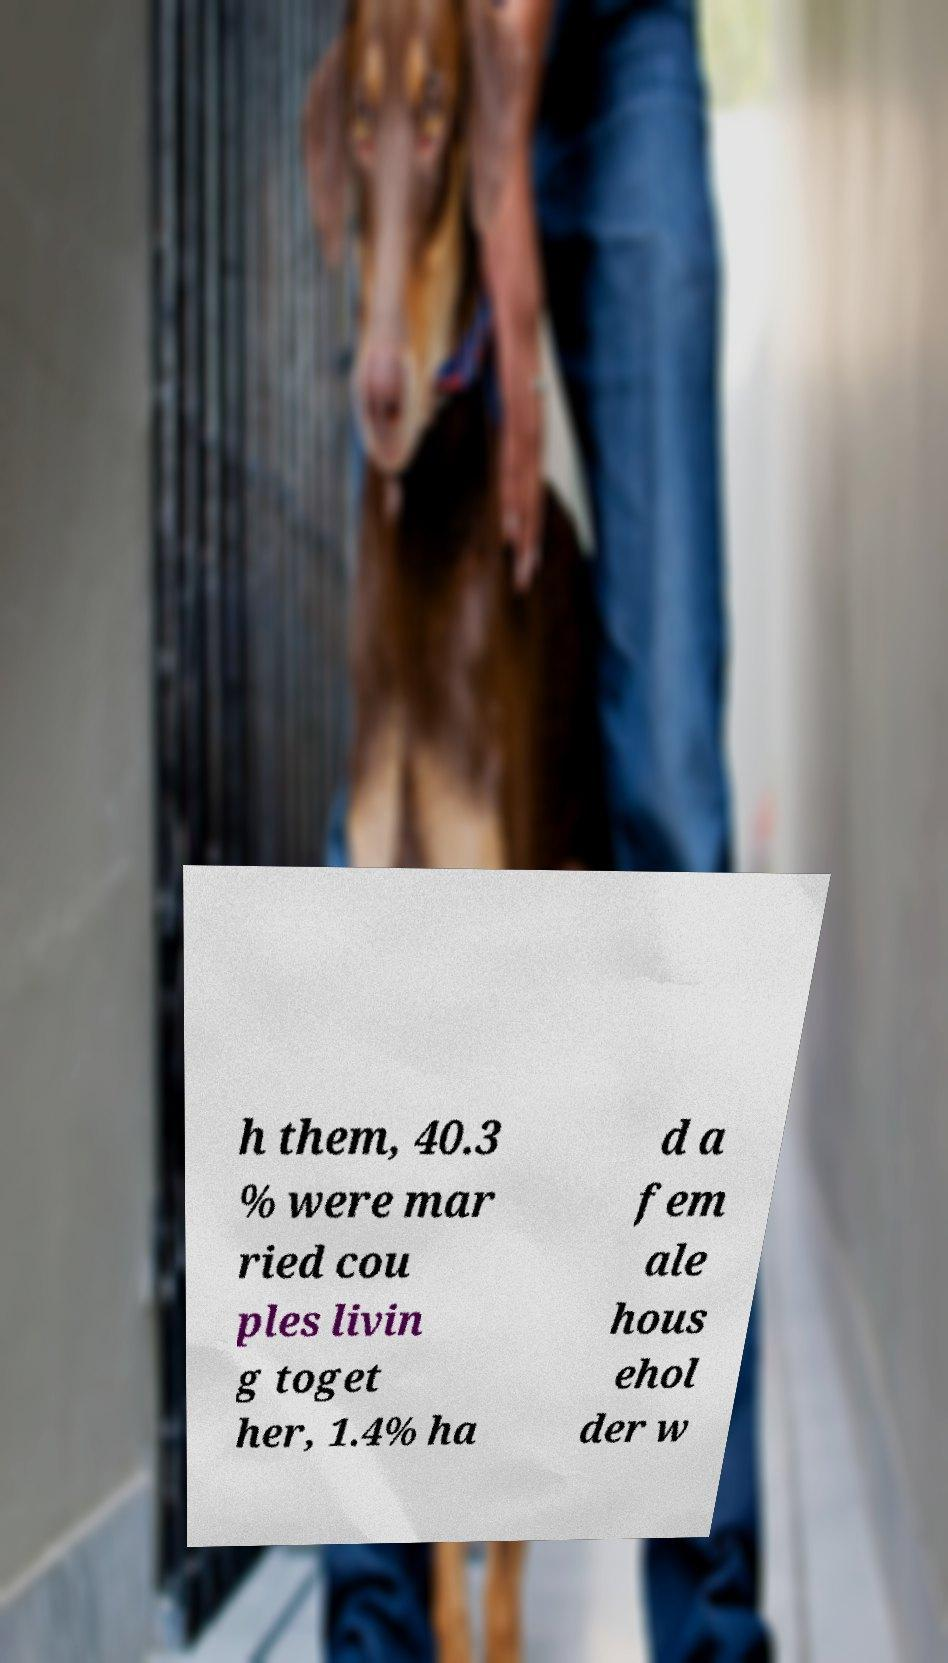Could you assist in decoding the text presented in this image and type it out clearly? h them, 40.3 % were mar ried cou ples livin g toget her, 1.4% ha d a fem ale hous ehol der w 